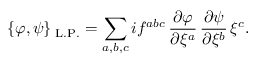<formula> <loc_0><loc_0><loc_500><loc_500>\{ \varphi , \psi \} _ { \mathrm { L . P . } } = \sum _ { a , b , c } i f ^ { a b c } \, \frac { \partial \varphi } { \partial \xi ^ { a } } \, \frac { \partial \psi } { \partial \xi ^ { b } } \, \xi ^ { c } .</formula> 